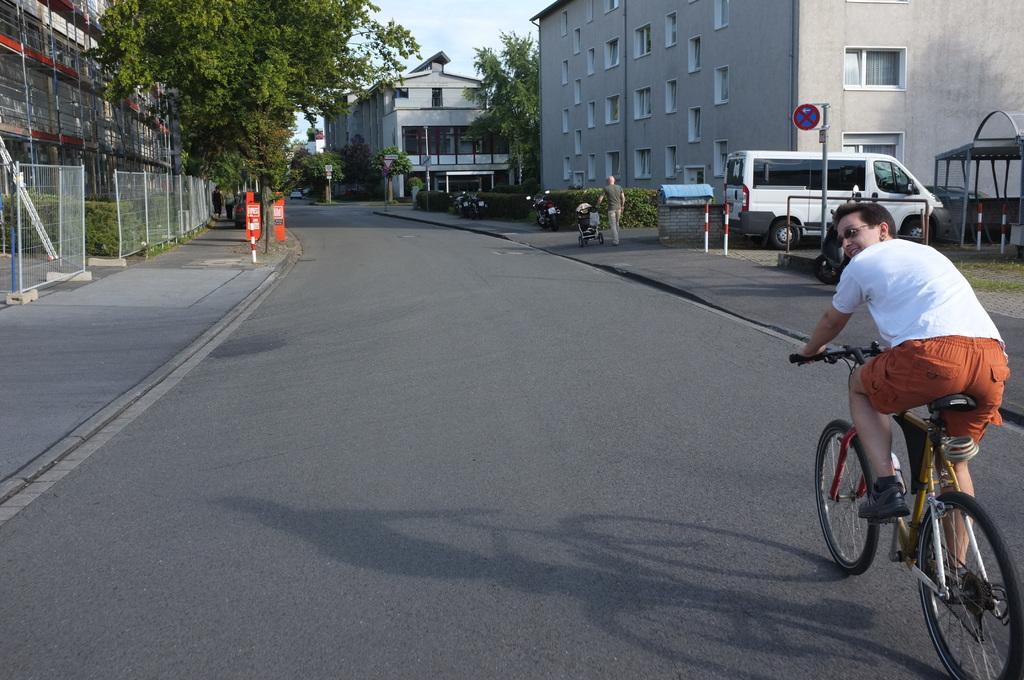What is the man doing in the image? The man is riding a bicycle on the road. What else can be seen on the road in the image? There is a vehicle in the image. What structures are visible in the image? There are buildings in the image. What type of natural elements can be seen in the image? There are trees in the image. What part of the natural environment is visible in the image? The sky is visible in the image. What type of barrier is present in the image? There is a fence in the image. What type of vegetation is present on either side of the road? Small plants are present on either side of the road. What type of property can be seen in the image? There is no specific property mentioned or depicted in the image. What selection of animals can be seen in the image? There are no animals present in the image; it features a man riding a bicycle, a vehicle, buildings, trees, the sky, a fence, and small plants. 